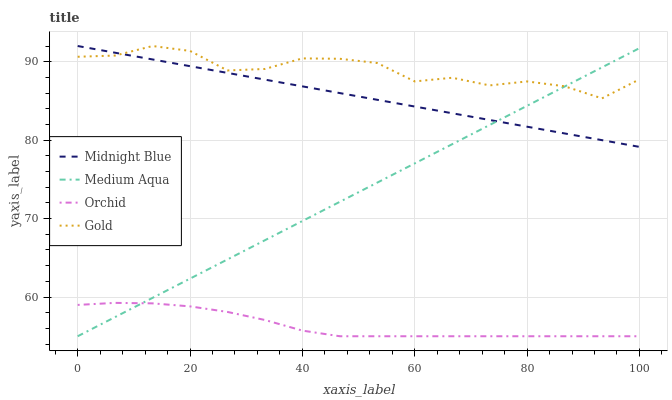Does Orchid have the minimum area under the curve?
Answer yes or no. Yes. Does Gold have the maximum area under the curve?
Answer yes or no. Yes. Does Midnight Blue have the minimum area under the curve?
Answer yes or no. No. Does Midnight Blue have the maximum area under the curve?
Answer yes or no. No. Is Midnight Blue the smoothest?
Answer yes or no. Yes. Is Gold the roughest?
Answer yes or no. Yes. Is Gold the smoothest?
Answer yes or no. No. Is Midnight Blue the roughest?
Answer yes or no. No. Does Midnight Blue have the lowest value?
Answer yes or no. No. Does Gold have the highest value?
Answer yes or no. Yes. Does Orchid have the highest value?
Answer yes or no. No. Is Orchid less than Midnight Blue?
Answer yes or no. Yes. Is Midnight Blue greater than Orchid?
Answer yes or no. Yes. Does Gold intersect Medium Aqua?
Answer yes or no. Yes. Is Gold less than Medium Aqua?
Answer yes or no. No. Is Gold greater than Medium Aqua?
Answer yes or no. No. Does Orchid intersect Midnight Blue?
Answer yes or no. No. 